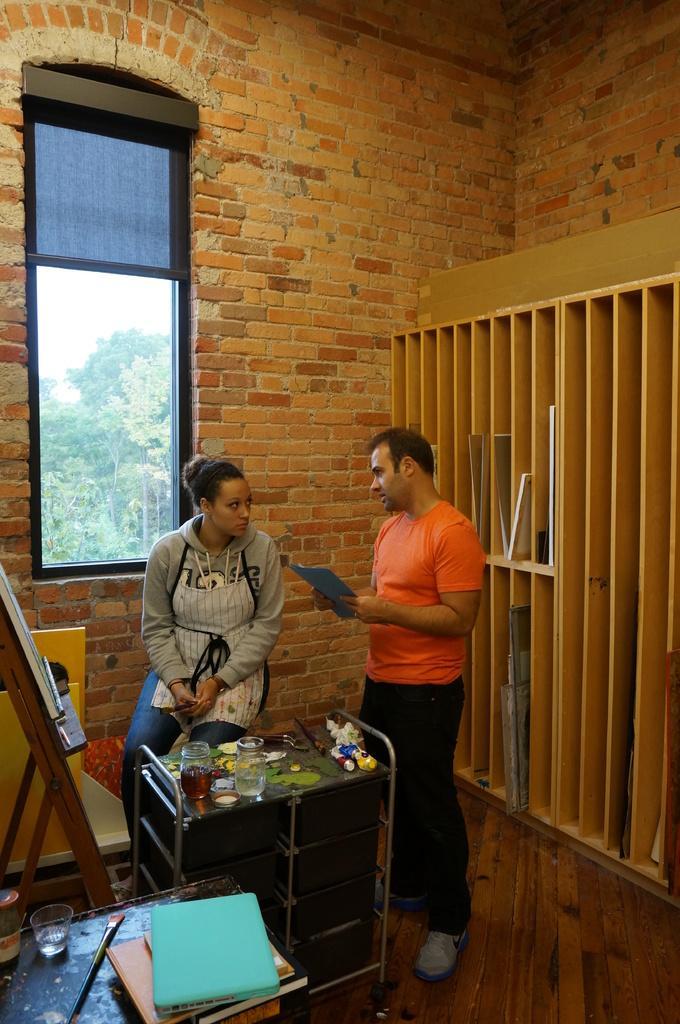How would you summarize this image in a sentence or two? In this picture there are two people standing and in front of them there is a table containing food items. In the background there is a wooden shelf filled with objects and there is a glass window. 